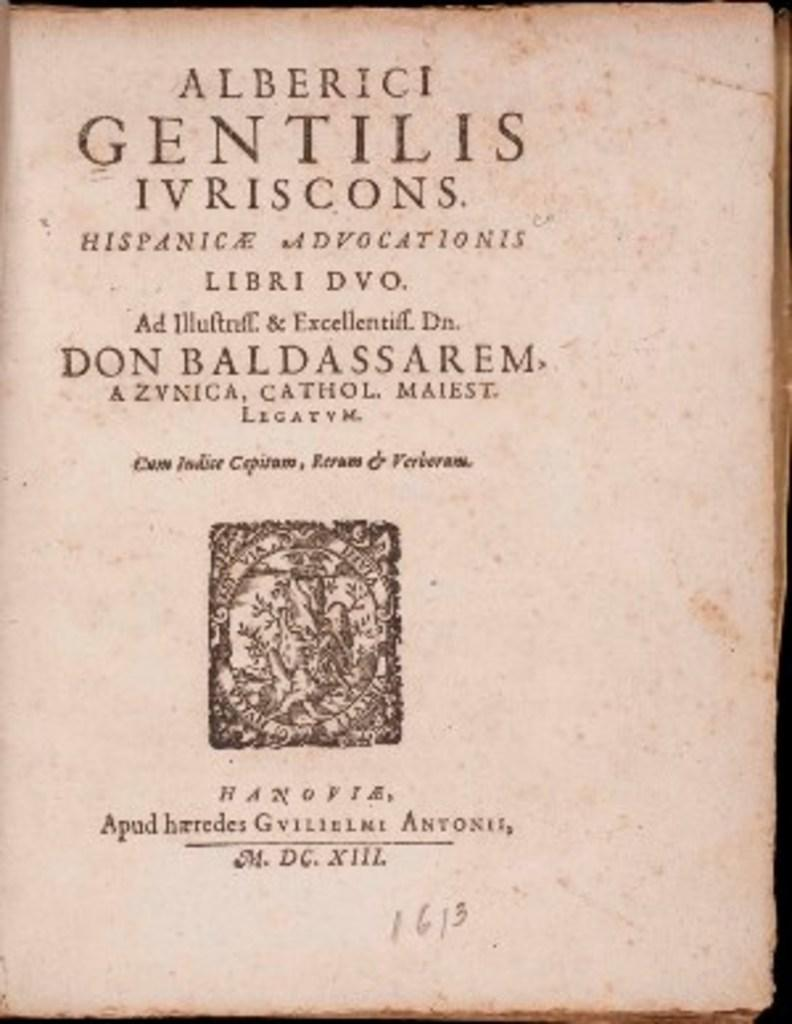<image>
Describe the image concisely. A very old book, the first word written at the top is Alberici. 